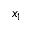Convert formula to latex. <formula><loc_0><loc_0><loc_500><loc_500>x _ { 1 }</formula> 